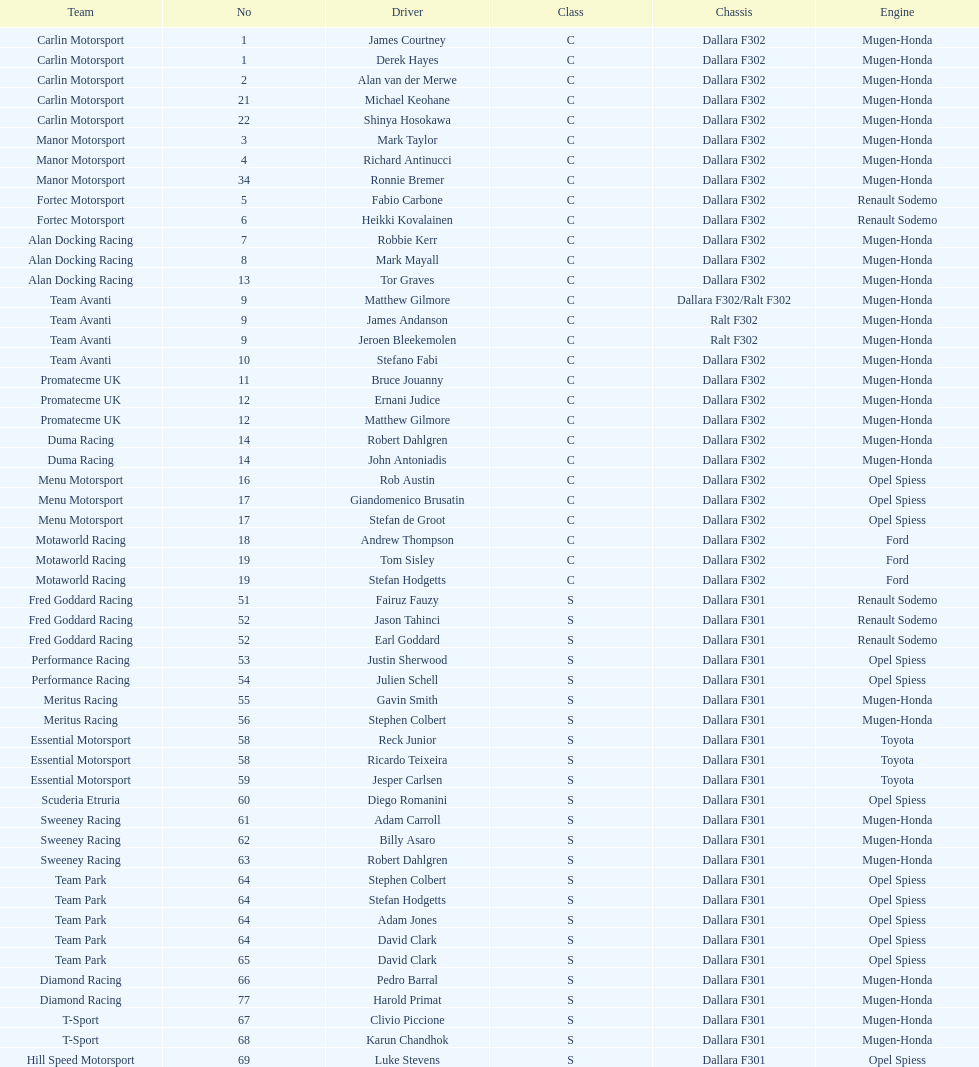Which team had a higher number of drivers, avanti or motaworld racing? Team Avanti. 